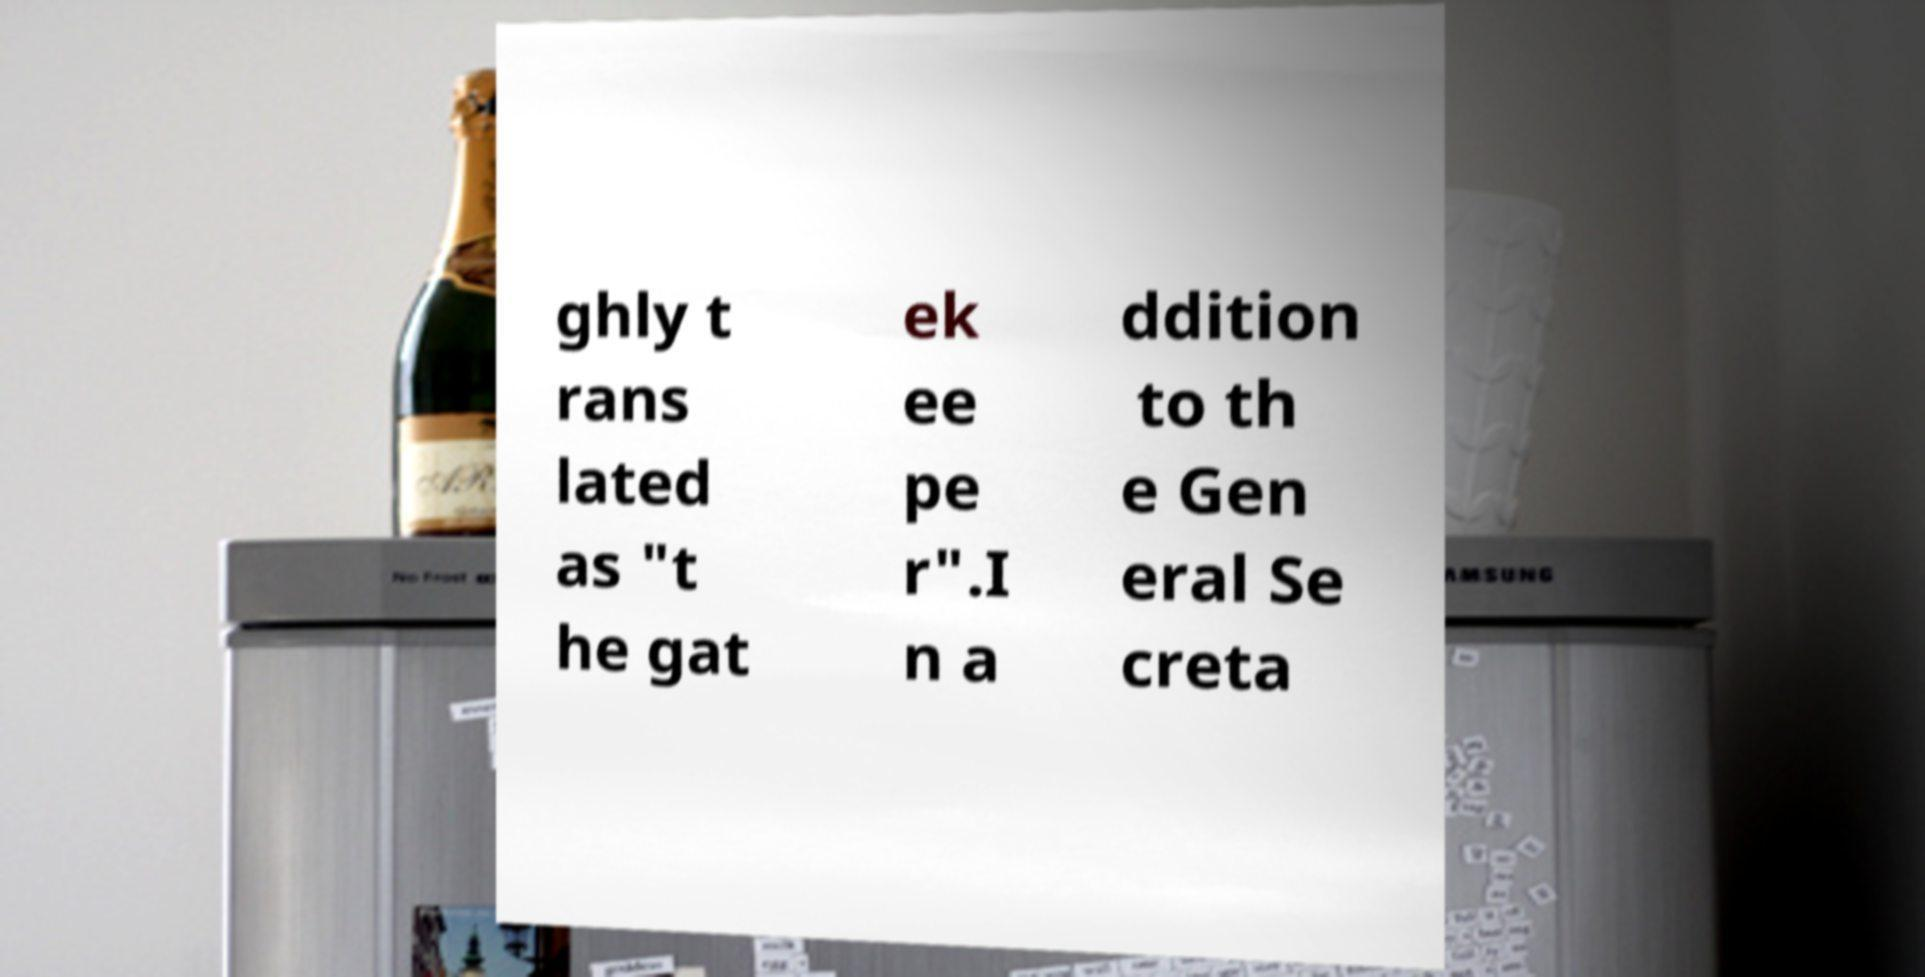Please read and relay the text visible in this image. What does it say? ghly t rans lated as "t he gat ek ee pe r".I n a ddition to th e Gen eral Se creta 